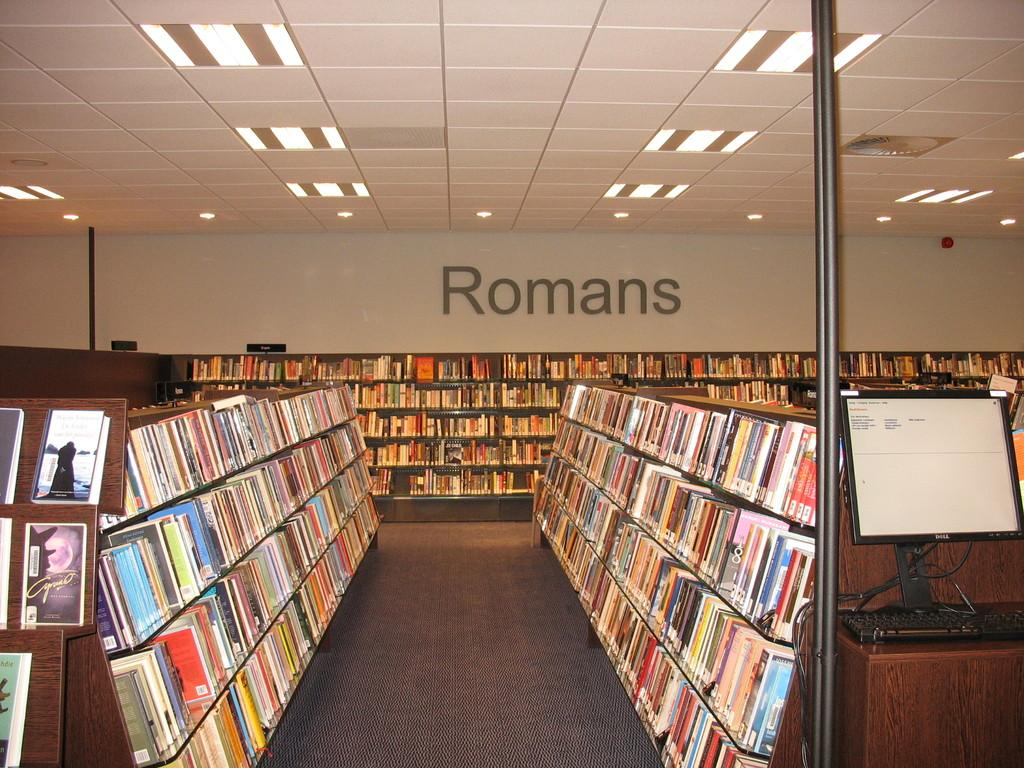<image>
Describe the image concisely. A large number of romans books neatly stacked on shelves. 